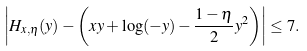<formula> <loc_0><loc_0><loc_500><loc_500>\left | H _ { x , \eta } ( y ) - \left ( x y + \log ( - y ) - \frac { 1 - \eta } { 2 } y ^ { 2 } \right ) \right | \leq 7 .</formula> 